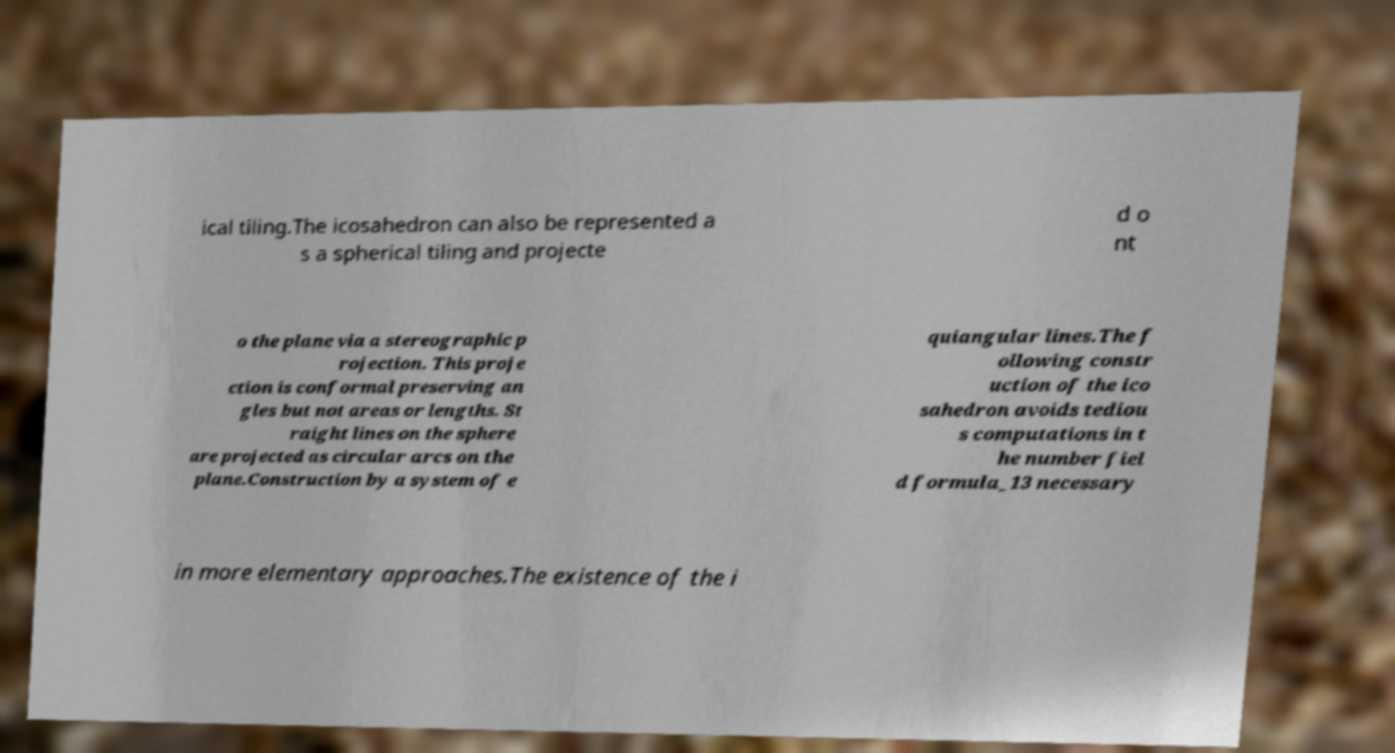Could you extract and type out the text from this image? ical tiling.The icosahedron can also be represented a s a spherical tiling and projecte d o nt o the plane via a stereographic p rojection. This proje ction is conformal preserving an gles but not areas or lengths. St raight lines on the sphere are projected as circular arcs on the plane.Construction by a system of e quiangular lines.The f ollowing constr uction of the ico sahedron avoids tediou s computations in t he number fiel d formula_13 necessary in more elementary approaches.The existence of the i 